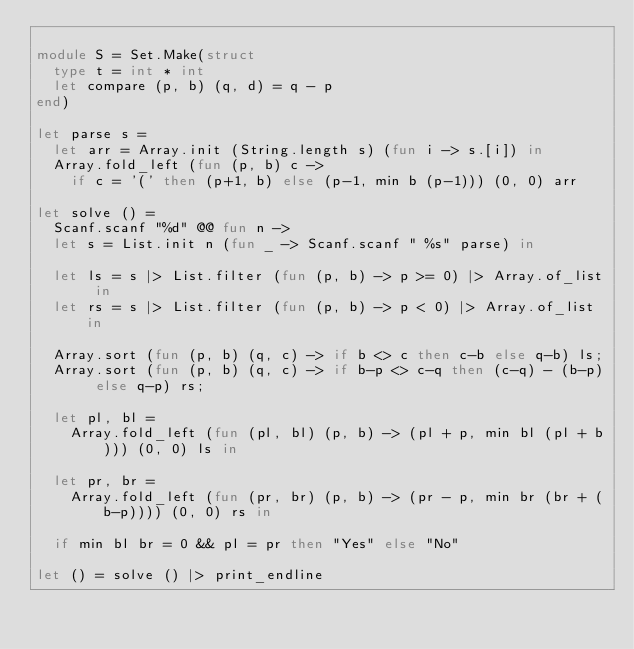Convert code to text. <code><loc_0><loc_0><loc_500><loc_500><_OCaml_>
module S = Set.Make(struct
  type t = int * int
  let compare (p, b) (q, d) = q - p
end)

let parse s =
  let arr = Array.init (String.length s) (fun i -> s.[i]) in
  Array.fold_left (fun (p, b) c ->
    if c = '(' then (p+1, b) else (p-1, min b (p-1))) (0, 0) arr

let solve () =
  Scanf.scanf "%d" @@ fun n ->
  let s = List.init n (fun _ -> Scanf.scanf " %s" parse) in

  let ls = s |> List.filter (fun (p, b) -> p >= 0) |> Array.of_list in
  let rs = s |> List.filter (fun (p, b) -> p < 0) |> Array.of_list in

  Array.sort (fun (p, b) (q, c) -> if b <> c then c-b else q-b) ls;
  Array.sort (fun (p, b) (q, c) -> if b-p <> c-q then (c-q) - (b-p) else q-p) rs;

  let pl, bl =
    Array.fold_left (fun (pl, bl) (p, b) -> (pl + p, min bl (pl + b))) (0, 0) ls in

  let pr, br =
    Array.fold_left (fun (pr, br) (p, b) -> (pr - p, min br (br + (b-p)))) (0, 0) rs in

  if min bl br = 0 && pl = pr then "Yes" else "No"

let () = solve () |> print_endline
</code> 